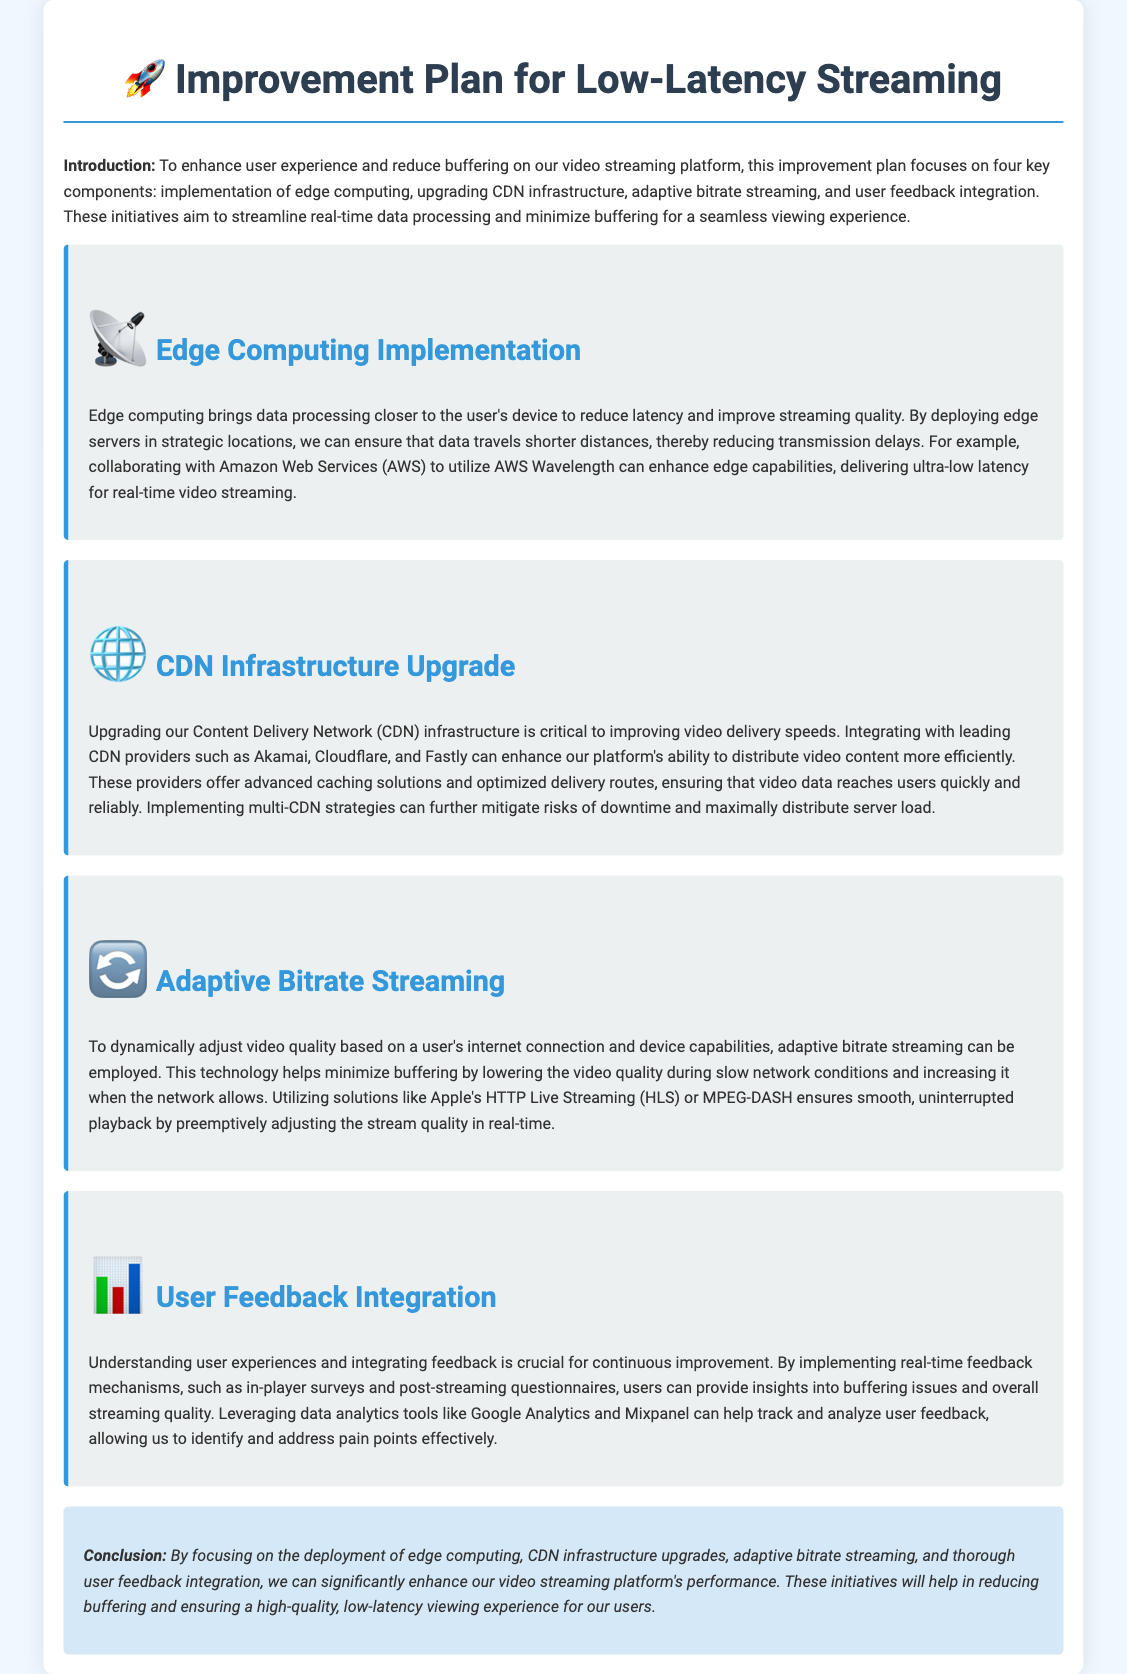What are the four key components of the improvement plan? The document lists four key components aimed at enhancing user experience and reducing buffering: edge computing, CDN infrastructure upgrades, adaptive bitrate streaming, and user feedback integration.
Answer: edge computing, CDN infrastructure upgrades, adaptive bitrate streaming, user feedback integration What is the purpose of edge computing? Edge computing aims to bring data processing closer to the user's device to reduce latency and improve streaming quality.
Answer: reduce latency Which CDN providers are mentioned in the document? The document specifies several leading CDN providers that can enhance the platform's ability to distribute video content: Akamai, Cloudflare, and Fastly.
Answer: Akamai, Cloudflare, Fastly What technology is used for adaptive bitrate streaming? The document mentions Apple's HTTP Live Streaming (HLS) and MPEG-DASH as solutions for adaptive bitrate streaming that ensure smooth playback.
Answer: Apple's HTTP Live Streaming (HLS), MPEG-DASH How does user feedback contribute to the improvement plan? User feedback is integrated through real-time feedback mechanisms, which helps to understand user experiences and identify pain points effectively.
Answer: identify pain points What kind of strategies can mitigate risks of downtime? The document mentions implementing multi-CDN strategies as a way to mitigate risks of downtime and distribute server load.
Answer: multi-CDN strategies What is the main goal of the improvement plan? The primary goal of the improvement plan is to enhance user experience and reduce buffering on the video streaming platform.
Answer: enhance user experience and reduce buffering What type of data analytics tools are mentioned for tracking user feedback? Data analytics tools such as Google Analytics and Mixpanel are mentioned in the document for tracking and analyzing user feedback.
Answer: Google Analytics, Mixpanel 